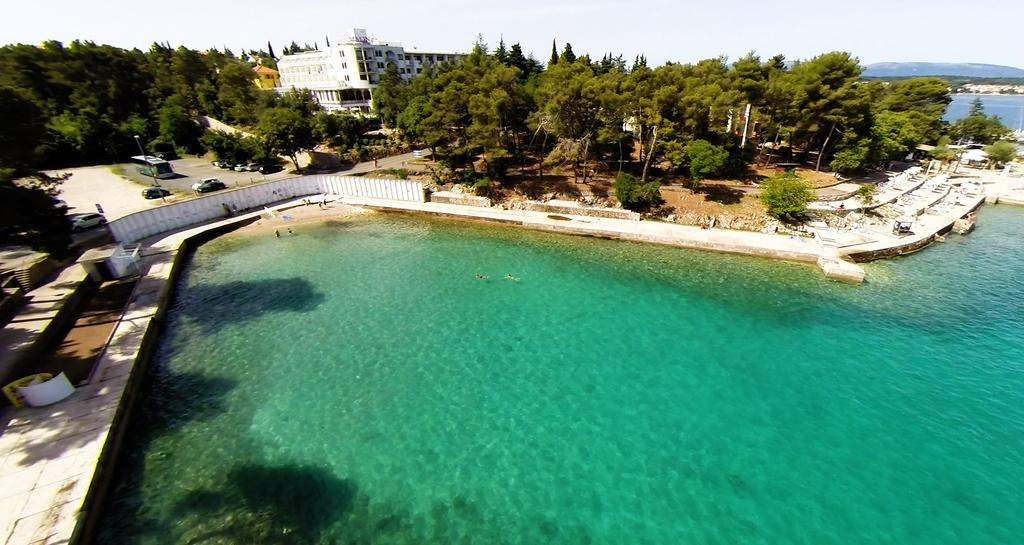What type of natural feature can be seen in the image? There is a lake in the image. What type of man-made structure is visible in the image? There is a building in the image. What type of vegetation is present in the image? Trees are present in the image. What type of transportation is visible in the image? There are vehicles on the road in the image. What is visible at the top of the image? The sky is visible at the top of the image. What type of competition is taking place in the image? There is no competition present in the image. How does the heat affect the vehicles in the image? There is no information about the temperature or heat in the image, and no specific effects on the vehicles can be observed. 